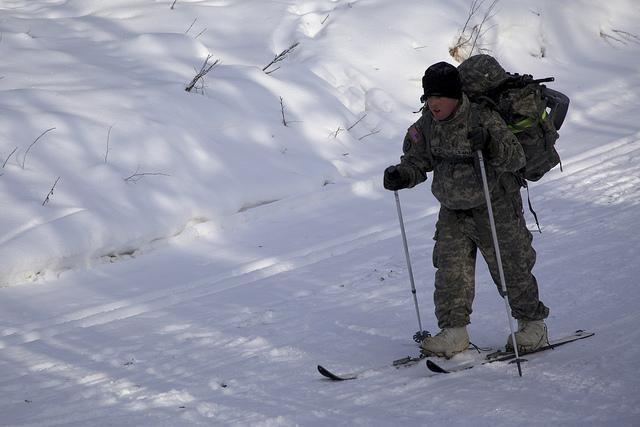How many skiers are there?
Give a very brief answer. 1. 